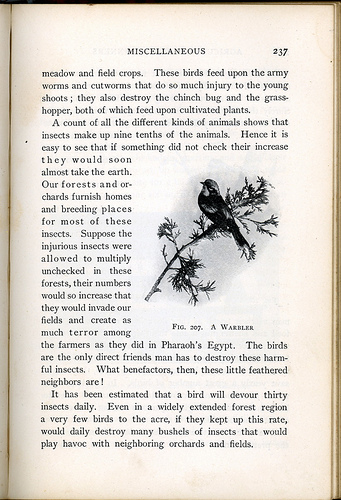<image>What colleges library Icelandic collection? It is unknown which college's library collects Icelandic materials. It could be Yale, Harvard, or UCC. What colleges library Icelandic collection? I don't know which colleges library Icelandic collection. It can be Yale, Harvard or UCC. 